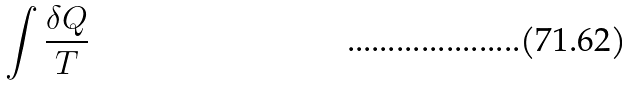<formula> <loc_0><loc_0><loc_500><loc_500>\int \frac { \delta Q } { T }</formula> 